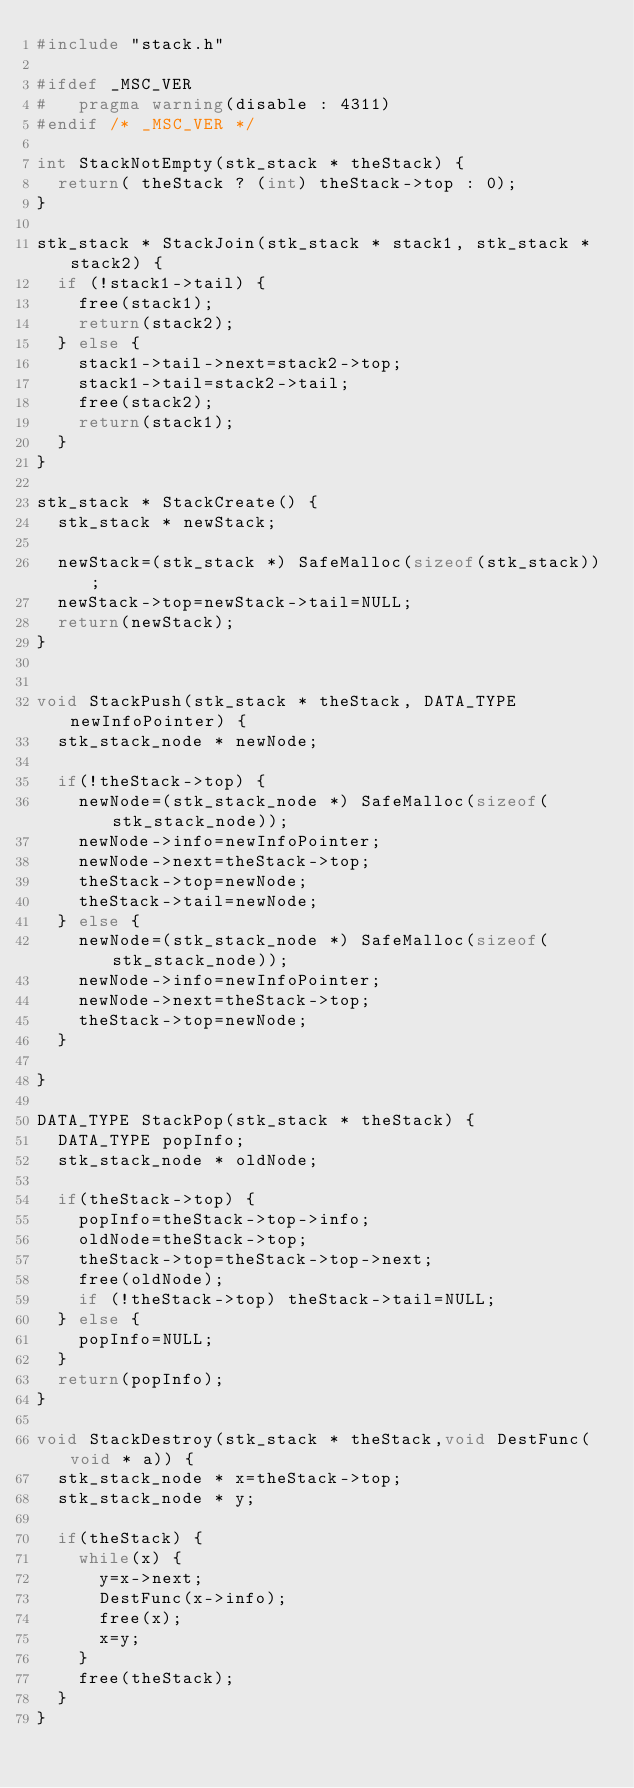<code> <loc_0><loc_0><loc_500><loc_500><_C_>#include "stack.h"

#ifdef _MSC_VER
#	pragma warning(disable : 4311)
#endif /* _MSC_VER */

int StackNotEmpty(stk_stack * theStack) {
  return( theStack ? (int) theStack->top : 0);
}

stk_stack * StackJoin(stk_stack * stack1, stk_stack * stack2) {
  if (!stack1->tail) {
    free(stack1);
    return(stack2);
  } else {
    stack1->tail->next=stack2->top;
    stack1->tail=stack2->tail;
    free(stack2);
    return(stack1);
  }
}

stk_stack * StackCreate() {
  stk_stack * newStack;
  
  newStack=(stk_stack *) SafeMalloc(sizeof(stk_stack));
  newStack->top=newStack->tail=NULL;
  return(newStack);
}


void StackPush(stk_stack * theStack, DATA_TYPE newInfoPointer) {
  stk_stack_node * newNode;

  if(!theStack->top) {
    newNode=(stk_stack_node *) SafeMalloc(sizeof(stk_stack_node));
    newNode->info=newInfoPointer;
    newNode->next=theStack->top;
    theStack->top=newNode;
    theStack->tail=newNode;
  } else {
    newNode=(stk_stack_node *) SafeMalloc(sizeof(stk_stack_node));
    newNode->info=newInfoPointer;
    newNode->next=theStack->top;
    theStack->top=newNode;
  }
  
}

DATA_TYPE StackPop(stk_stack * theStack) {
  DATA_TYPE popInfo;
  stk_stack_node * oldNode;

  if(theStack->top) {
    popInfo=theStack->top->info;
    oldNode=theStack->top;
    theStack->top=theStack->top->next;
    free(oldNode);
    if (!theStack->top) theStack->tail=NULL;
  } else {
    popInfo=NULL;
  }
  return(popInfo);
}

void StackDestroy(stk_stack * theStack,void DestFunc(void * a)) {
  stk_stack_node * x=theStack->top;
  stk_stack_node * y;

  if(theStack) {
    while(x) {
      y=x->next;
      DestFunc(x->info);
      free(x);
      x=y;
    }
    free(theStack);
  }
} 
    
</code> 